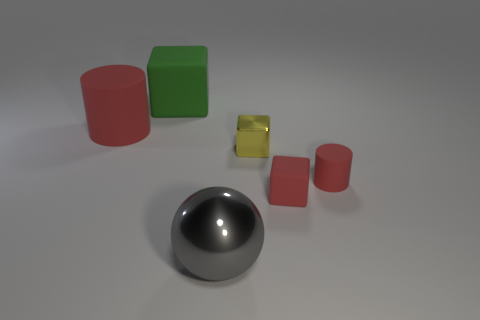Subtract all green matte cubes. How many cubes are left? 2 Subtract 1 cubes. How many cubes are left? 2 Add 2 large yellow metal balls. How many objects exist? 8 Subtract all spheres. How many objects are left? 5 Subtract all cyan blocks. Subtract all brown balls. How many blocks are left? 3 Subtract 1 yellow blocks. How many objects are left? 5 Subtract all matte cubes. Subtract all brown rubber things. How many objects are left? 4 Add 4 gray spheres. How many gray spheres are left? 5 Add 1 tiny green shiny blocks. How many tiny green shiny blocks exist? 1 